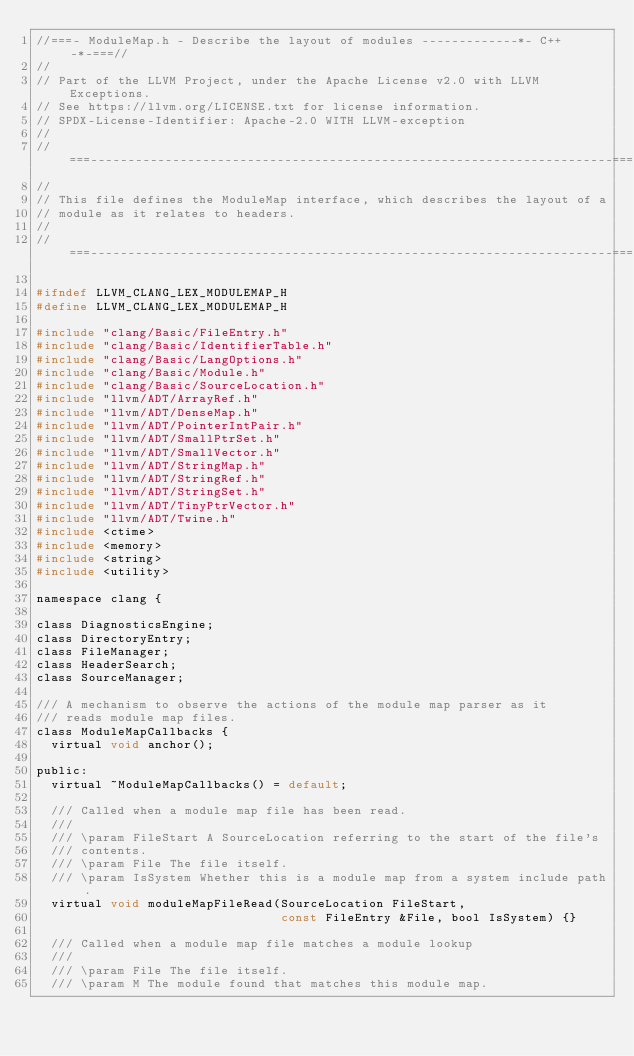Convert code to text. <code><loc_0><loc_0><loc_500><loc_500><_C_>//===- ModuleMap.h - Describe the layout of modules -------------*- C++ -*-===//
//
// Part of the LLVM Project, under the Apache License v2.0 with LLVM Exceptions.
// See https://llvm.org/LICENSE.txt for license information.
// SPDX-License-Identifier: Apache-2.0 WITH LLVM-exception
//
//===----------------------------------------------------------------------===//
//
// This file defines the ModuleMap interface, which describes the layout of a
// module as it relates to headers.
//
//===----------------------------------------------------------------------===//

#ifndef LLVM_CLANG_LEX_MODULEMAP_H
#define LLVM_CLANG_LEX_MODULEMAP_H

#include "clang/Basic/FileEntry.h"
#include "clang/Basic/IdentifierTable.h"
#include "clang/Basic/LangOptions.h"
#include "clang/Basic/Module.h"
#include "clang/Basic/SourceLocation.h"
#include "llvm/ADT/ArrayRef.h"
#include "llvm/ADT/DenseMap.h"
#include "llvm/ADT/PointerIntPair.h"
#include "llvm/ADT/SmallPtrSet.h"
#include "llvm/ADT/SmallVector.h"
#include "llvm/ADT/StringMap.h"
#include "llvm/ADT/StringRef.h"
#include "llvm/ADT/StringSet.h"
#include "llvm/ADT/TinyPtrVector.h"
#include "llvm/ADT/Twine.h"
#include <ctime>
#include <memory>
#include <string>
#include <utility>

namespace clang {

class DiagnosticsEngine;
class DirectoryEntry;
class FileManager;
class HeaderSearch;
class SourceManager;

/// A mechanism to observe the actions of the module map parser as it
/// reads module map files.
class ModuleMapCallbacks {
  virtual void anchor();

public:
  virtual ~ModuleMapCallbacks() = default;

  /// Called when a module map file has been read.
  ///
  /// \param FileStart A SourceLocation referring to the start of the file's
  /// contents.
  /// \param File The file itself.
  /// \param IsSystem Whether this is a module map from a system include path.
  virtual void moduleMapFileRead(SourceLocation FileStart,
                                 const FileEntry &File, bool IsSystem) {}

  /// Called when a module map file matches a module lookup
  ///
  /// \param File The file itself.
  /// \param M The module found that matches this module map.</code> 